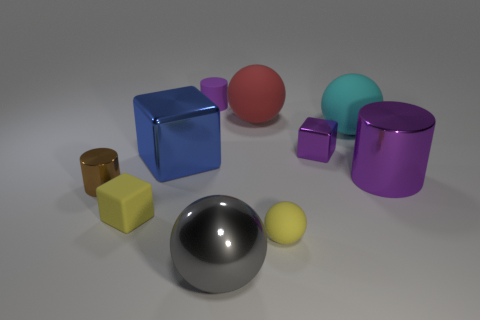What materials appear to be represented by the objects in the image? The objects in the image appear to be rendered to represent materials such as metal for the large gray sphere and the golden cube, matte surfaces for the red and blue cubes, a translucent finish for the teal sphere, and glossy finishes for the purple cylinder and blue cube. 